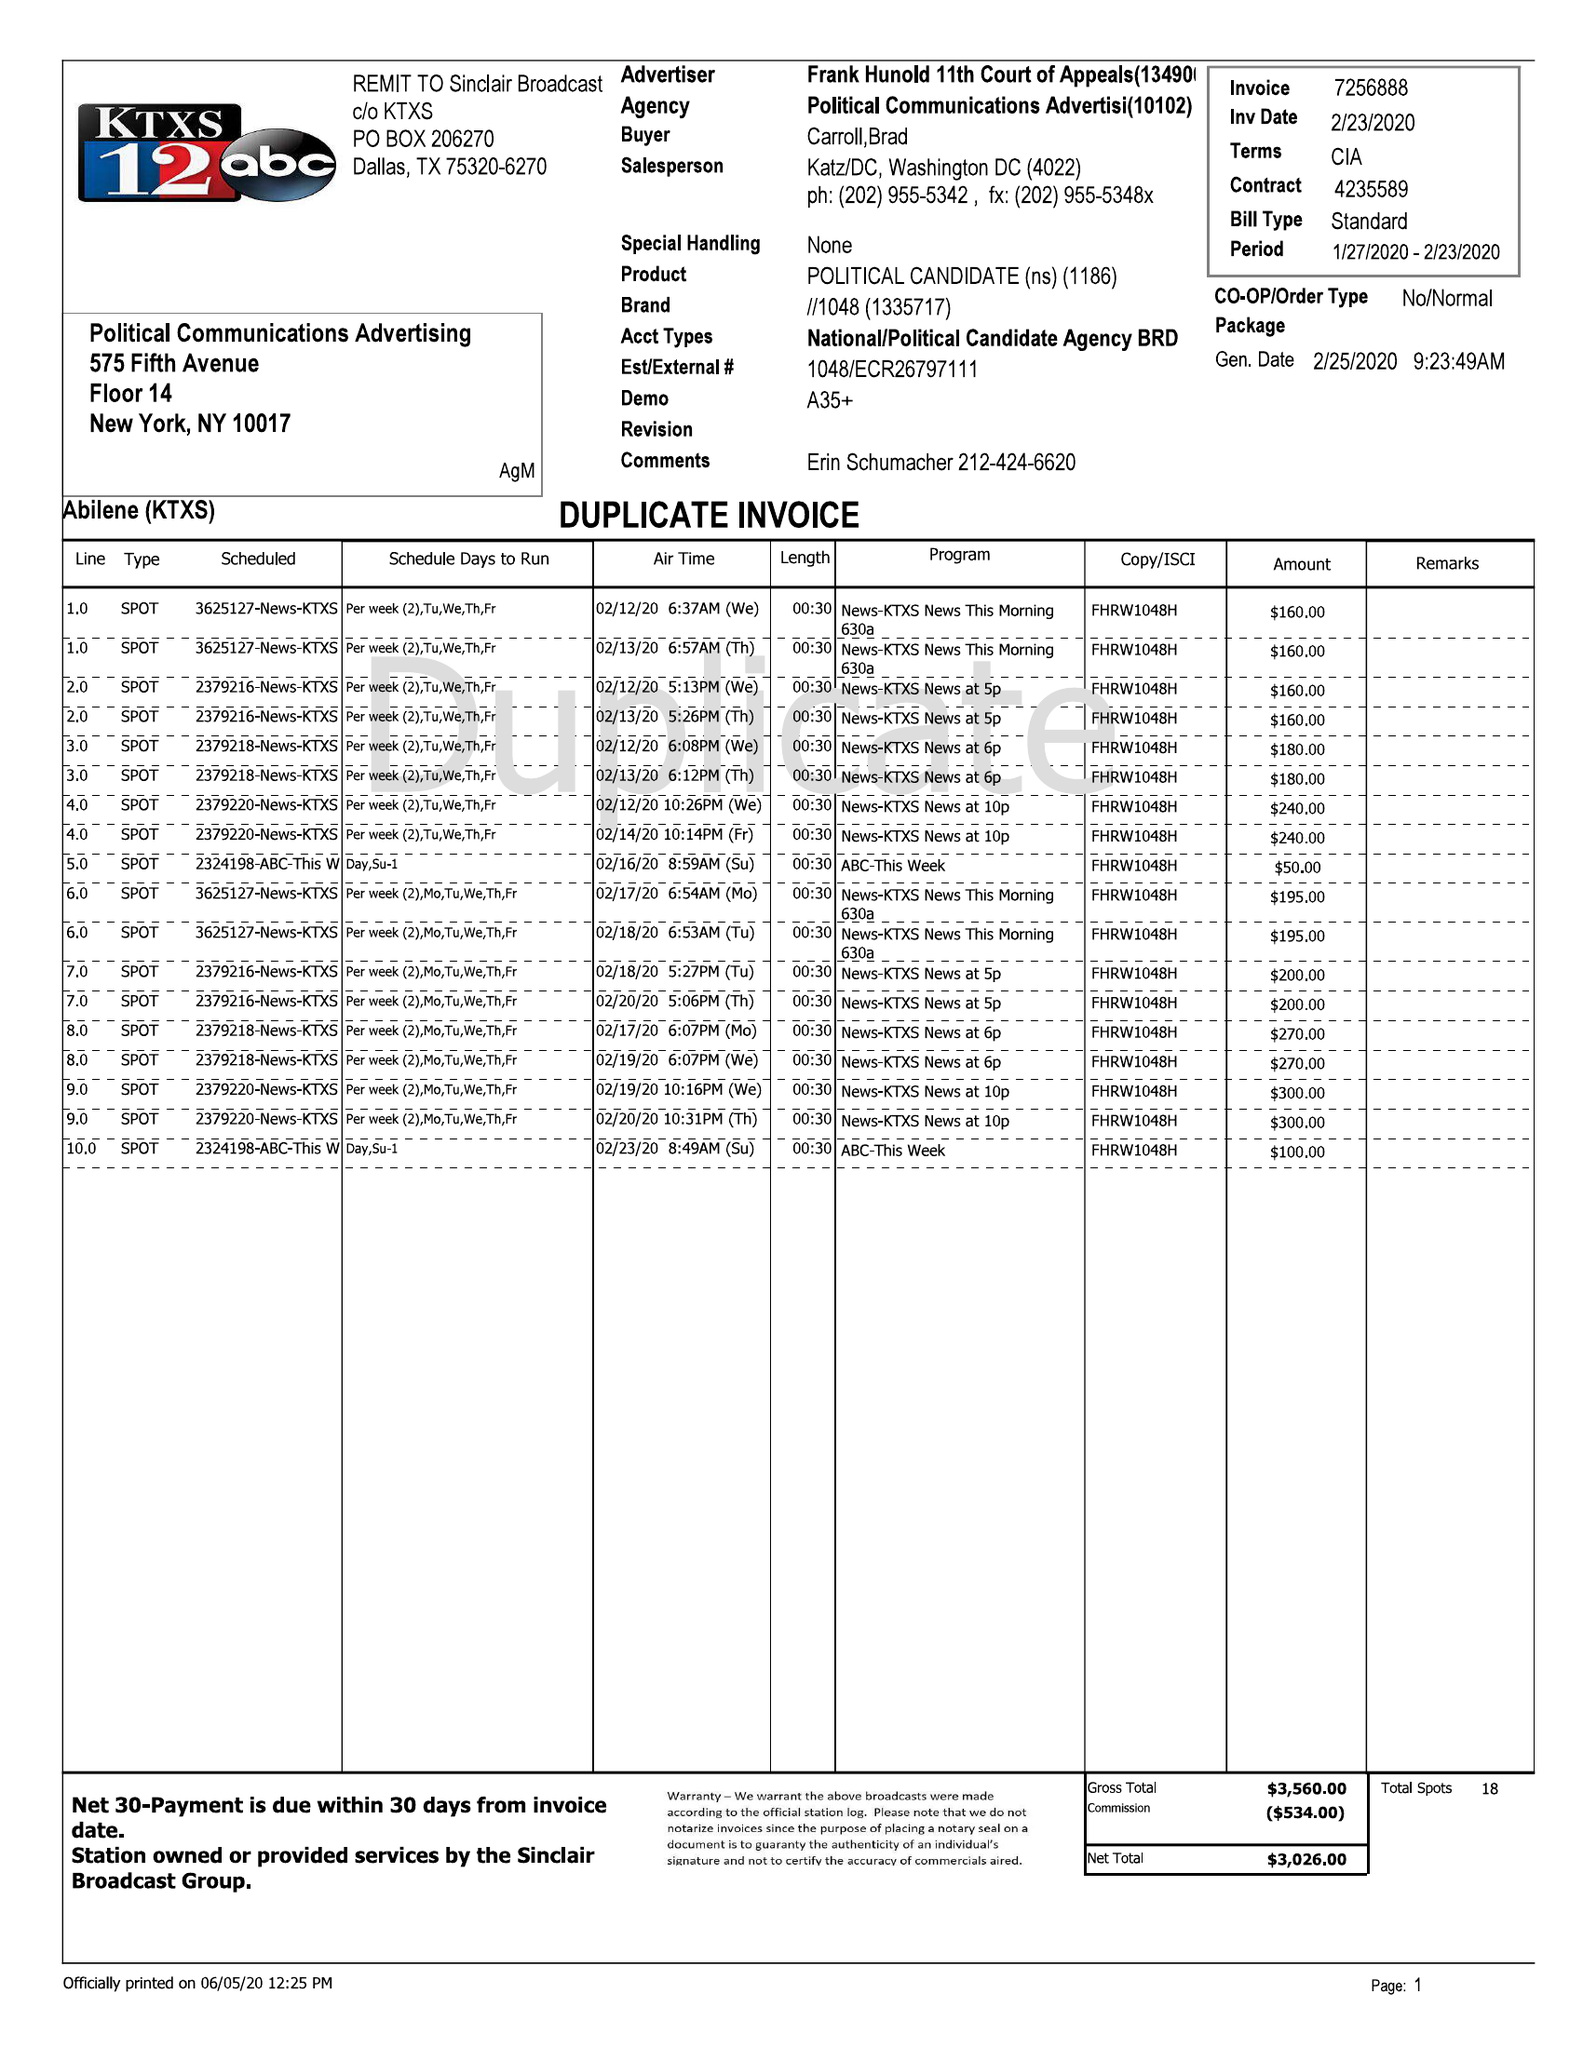What is the value for the flight_to?
Answer the question using a single word or phrase. 02/23/20 